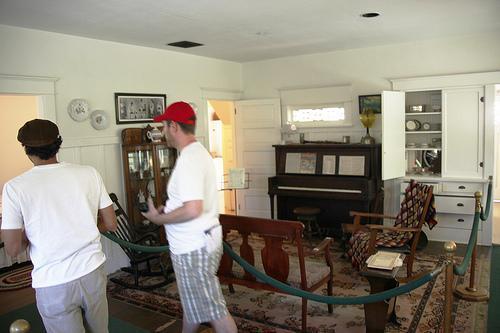How many me are facing us?
Give a very brief answer. 0. 